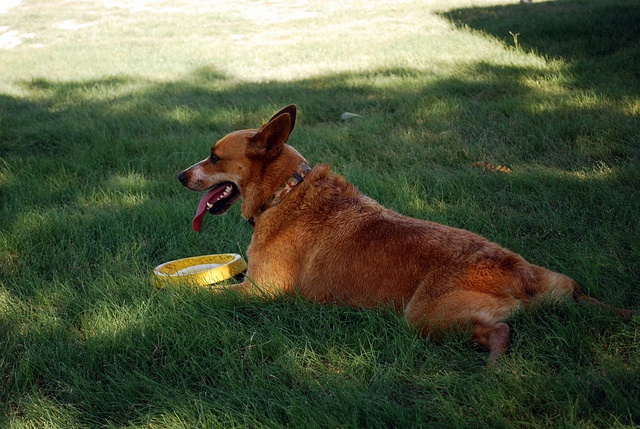Describe the objects in this image and their specific colors. I can see dog in white, maroon, black, and brown tones and bowl in white, olive, and tan tones in this image. 